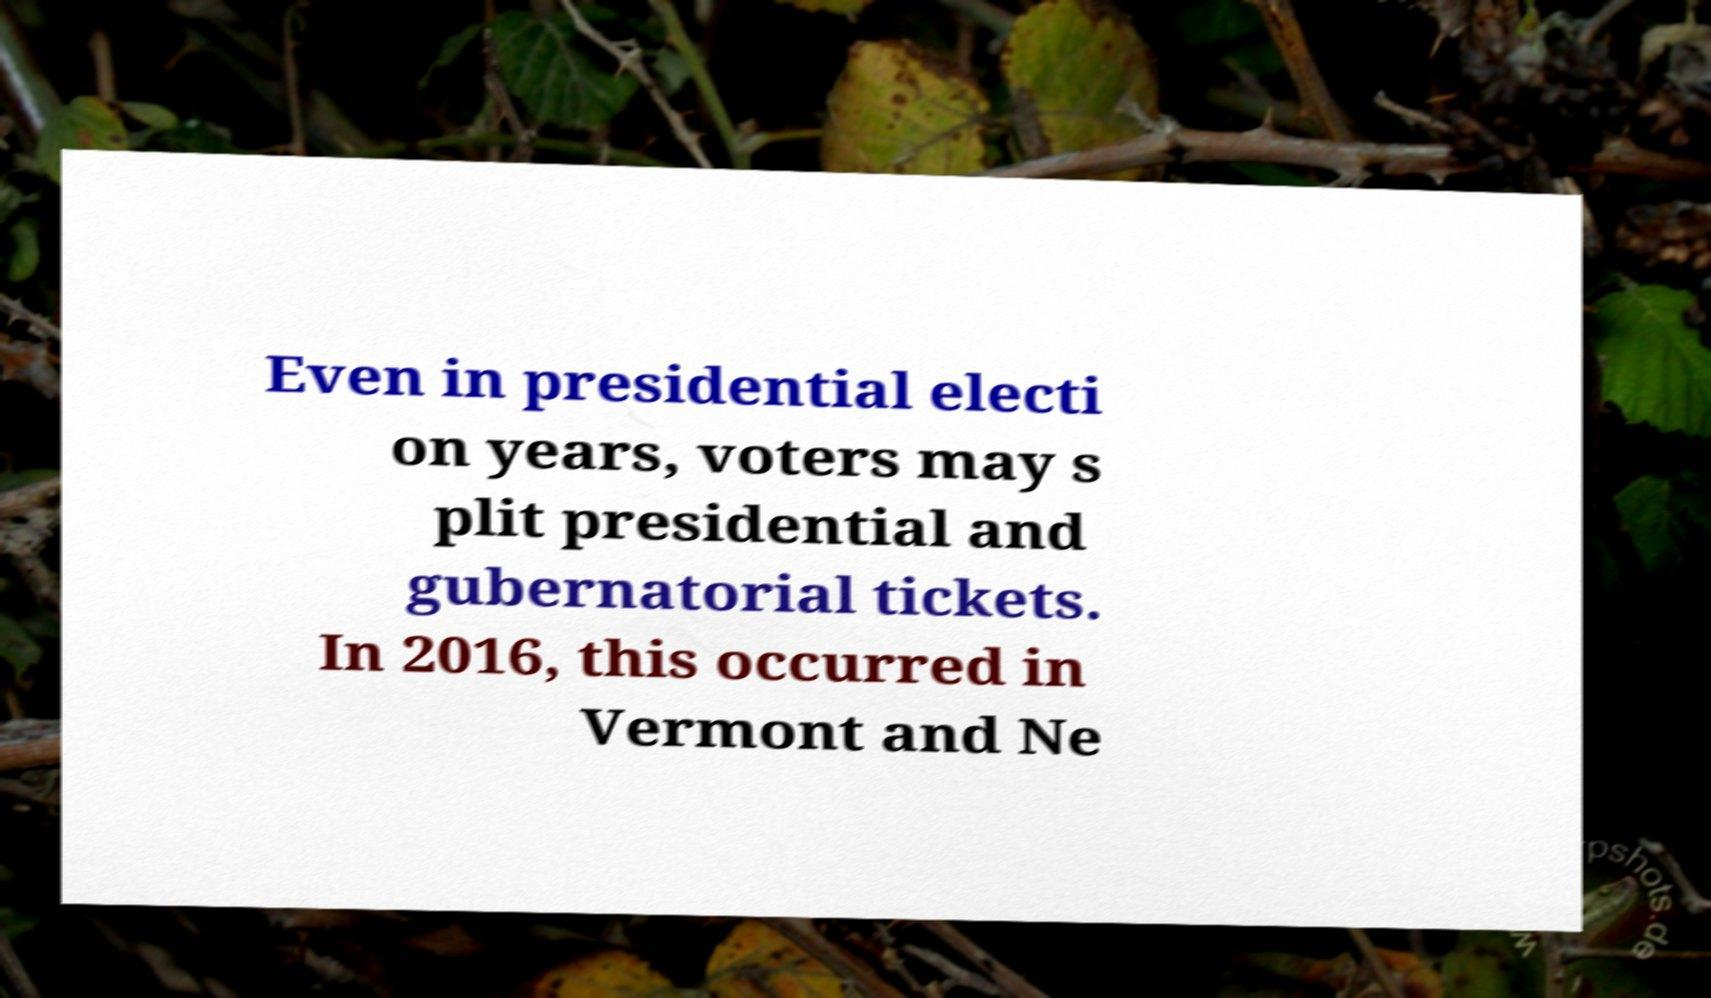For documentation purposes, I need the text within this image transcribed. Could you provide that? Even in presidential electi on years, voters may s plit presidential and gubernatorial tickets. In 2016, this occurred in Vermont and Ne 